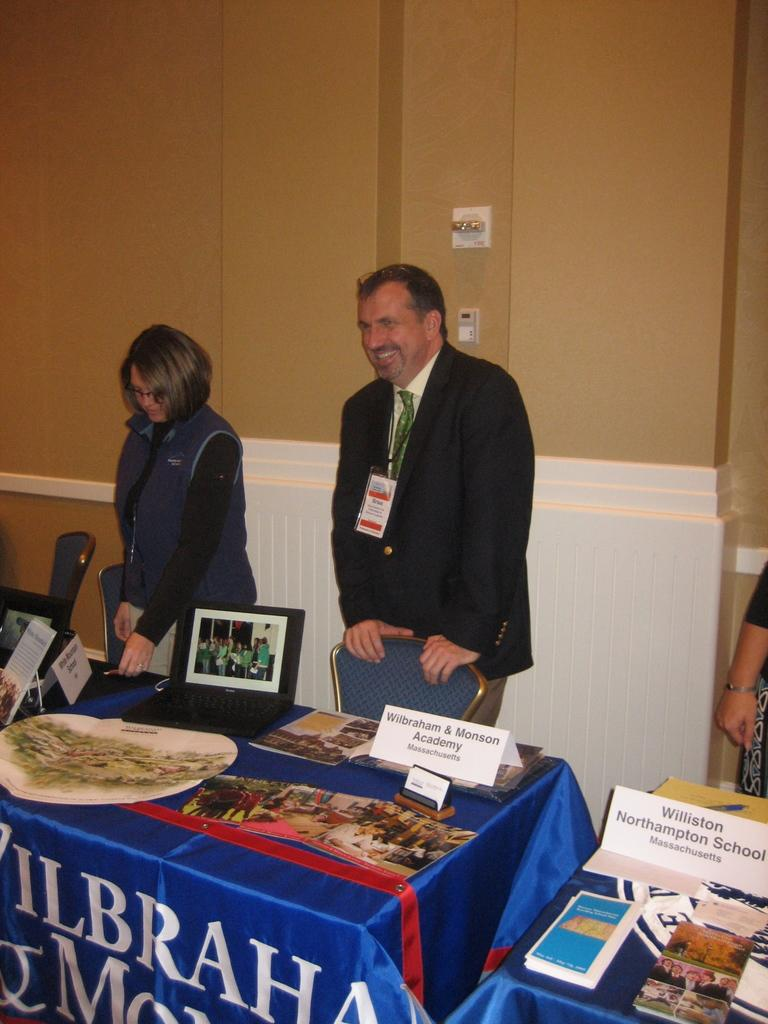<image>
Provide a brief description of the given image. Man and woman standing in front of a chair for Wilbraham and Monson Academy 